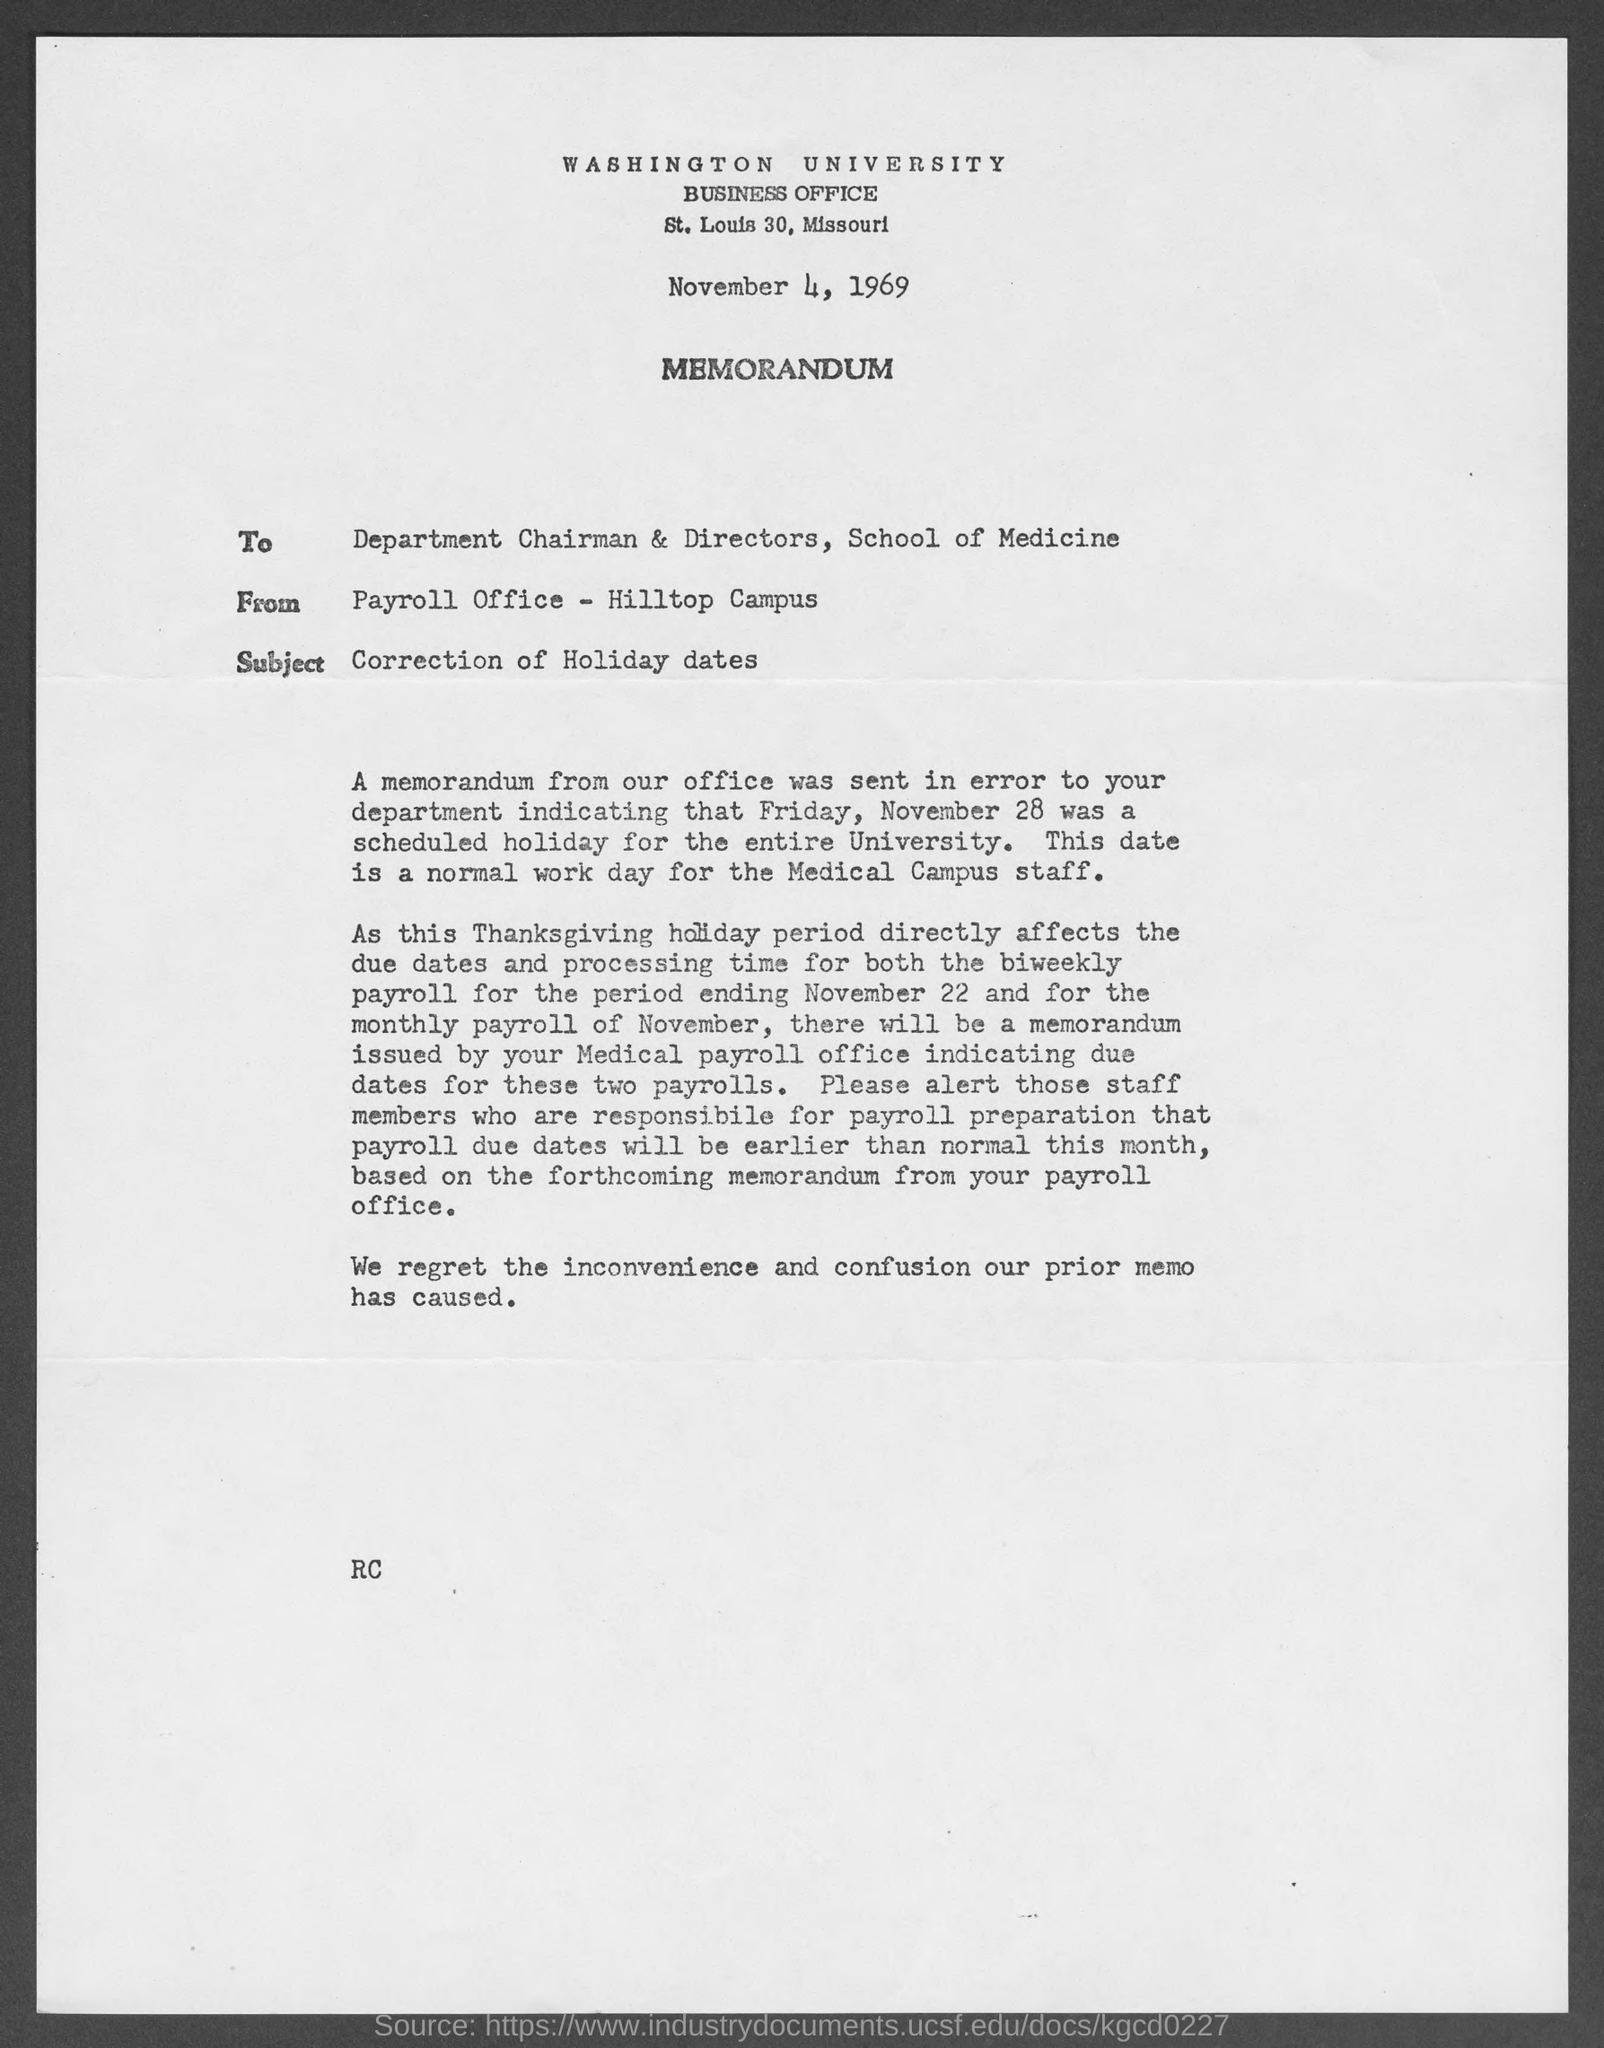Identify some key points in this picture. The subject of the memorandum is the correction of holiday dates. In a memorandum, the 'from' address refers to the individual or organization that originated the communication, namely the Payroll office located at Hilltop Campus. 